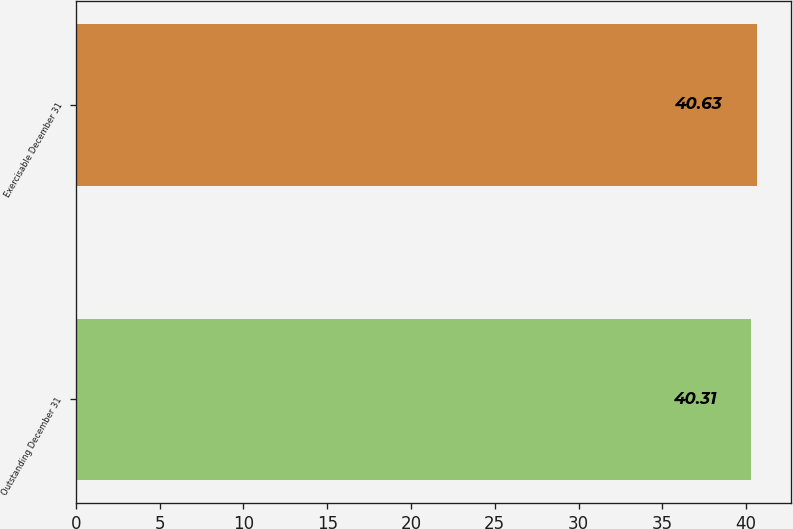Convert chart. <chart><loc_0><loc_0><loc_500><loc_500><bar_chart><fcel>Outstanding December 31<fcel>Exercisable December 31<nl><fcel>40.31<fcel>40.63<nl></chart> 